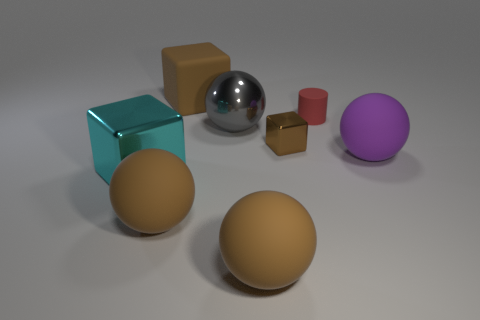Subtract all big purple spheres. How many spheres are left? 3 Subtract all brown blocks. How many blocks are left? 1 Add 2 cyan blocks. How many objects exist? 10 Subtract all blue cubes. How many brown spheres are left? 2 Subtract all cylinders. How many objects are left? 7 Subtract 1 spheres. How many spheres are left? 3 Subtract all cyan cylinders. Subtract all brown balls. How many cylinders are left? 1 Subtract all red objects. Subtract all red cylinders. How many objects are left? 6 Add 7 brown rubber cubes. How many brown rubber cubes are left? 8 Add 1 tiny yellow blocks. How many tiny yellow blocks exist? 1 